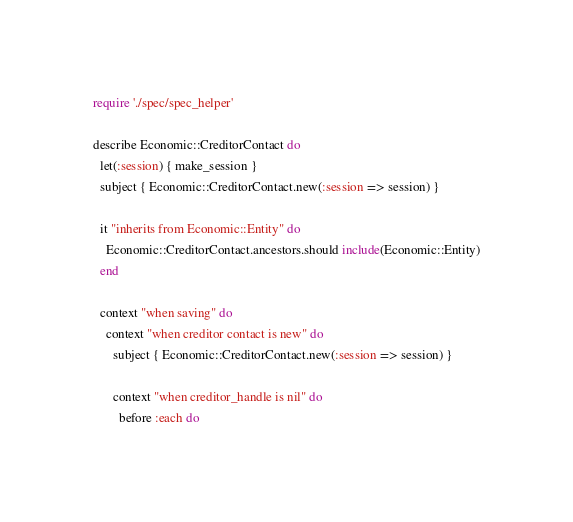Convert code to text. <code><loc_0><loc_0><loc_500><loc_500><_Ruby_>require './spec/spec_helper'

describe Economic::CreditorContact do
  let(:session) { make_session }
  subject { Economic::CreditorContact.new(:session => session) }

  it "inherits from Economic::Entity" do
    Economic::CreditorContact.ancestors.should include(Economic::Entity)
  end

  context "when saving" do
    context "when creditor contact is new" do
      subject { Economic::CreditorContact.new(:session => session) }

      context "when creditor_handle is nil" do
        before :each do</code> 